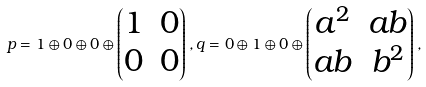Convert formula to latex. <formula><loc_0><loc_0><loc_500><loc_500>p = 1 \oplus 0 \oplus 0 \oplus \begin{pmatrix} 1 & 0 \\ 0 & 0 \end{pmatrix} , q = 0 \oplus 1 \oplus 0 \oplus \begin{pmatrix} a ^ { 2 } & a b \\ a b & b ^ { 2 } \end{pmatrix} ,</formula> 